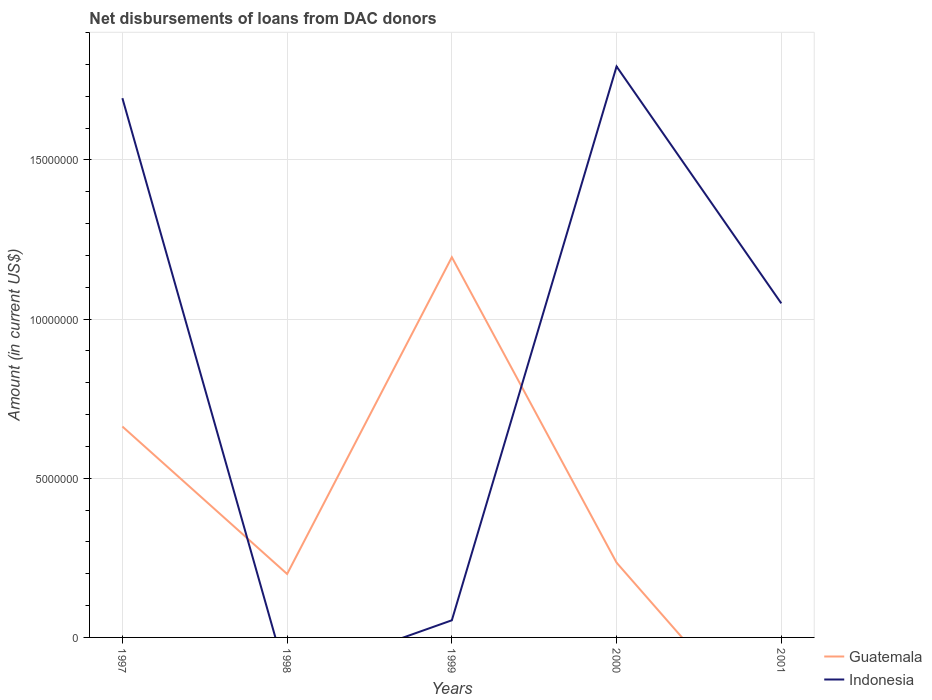Does the line corresponding to Indonesia intersect with the line corresponding to Guatemala?
Provide a succinct answer. Yes. Across all years, what is the maximum amount of loans disbursed in Guatemala?
Your response must be concise. 0. What is the total amount of loans disbursed in Guatemala in the graph?
Make the answer very short. -9.95e+06. What is the difference between the highest and the second highest amount of loans disbursed in Indonesia?
Give a very brief answer. 1.79e+07. Is the amount of loans disbursed in Indonesia strictly greater than the amount of loans disbursed in Guatemala over the years?
Your answer should be compact. No. What is the difference between two consecutive major ticks on the Y-axis?
Offer a very short reply. 5.00e+06. Are the values on the major ticks of Y-axis written in scientific E-notation?
Make the answer very short. No. Where does the legend appear in the graph?
Your answer should be very brief. Bottom right. How many legend labels are there?
Your answer should be compact. 2. What is the title of the graph?
Offer a terse response. Net disbursements of loans from DAC donors. What is the label or title of the X-axis?
Provide a succinct answer. Years. What is the label or title of the Y-axis?
Your answer should be compact. Amount (in current US$). What is the Amount (in current US$) in Guatemala in 1997?
Your answer should be very brief. 6.62e+06. What is the Amount (in current US$) in Indonesia in 1997?
Ensure brevity in your answer.  1.69e+07. What is the Amount (in current US$) in Guatemala in 1998?
Provide a succinct answer. 1.99e+06. What is the Amount (in current US$) of Guatemala in 1999?
Offer a terse response. 1.19e+07. What is the Amount (in current US$) of Indonesia in 1999?
Give a very brief answer. 5.38e+05. What is the Amount (in current US$) in Guatemala in 2000?
Your response must be concise. 2.35e+06. What is the Amount (in current US$) in Indonesia in 2000?
Provide a short and direct response. 1.79e+07. What is the Amount (in current US$) in Indonesia in 2001?
Offer a terse response. 1.05e+07. Across all years, what is the maximum Amount (in current US$) of Guatemala?
Offer a very short reply. 1.19e+07. Across all years, what is the maximum Amount (in current US$) of Indonesia?
Your answer should be very brief. 1.79e+07. Across all years, what is the minimum Amount (in current US$) of Guatemala?
Keep it short and to the point. 0. Across all years, what is the minimum Amount (in current US$) of Indonesia?
Offer a terse response. 0. What is the total Amount (in current US$) of Guatemala in the graph?
Offer a very short reply. 2.29e+07. What is the total Amount (in current US$) in Indonesia in the graph?
Make the answer very short. 4.59e+07. What is the difference between the Amount (in current US$) in Guatemala in 1997 and that in 1998?
Ensure brevity in your answer.  4.63e+06. What is the difference between the Amount (in current US$) in Guatemala in 1997 and that in 1999?
Give a very brief answer. -5.32e+06. What is the difference between the Amount (in current US$) in Indonesia in 1997 and that in 1999?
Provide a short and direct response. 1.64e+07. What is the difference between the Amount (in current US$) in Guatemala in 1997 and that in 2000?
Ensure brevity in your answer.  4.28e+06. What is the difference between the Amount (in current US$) of Indonesia in 1997 and that in 2000?
Make the answer very short. -9.96e+05. What is the difference between the Amount (in current US$) in Indonesia in 1997 and that in 2001?
Make the answer very short. 6.44e+06. What is the difference between the Amount (in current US$) of Guatemala in 1998 and that in 1999?
Your response must be concise. -9.95e+06. What is the difference between the Amount (in current US$) in Guatemala in 1998 and that in 2000?
Your answer should be compact. -3.56e+05. What is the difference between the Amount (in current US$) in Guatemala in 1999 and that in 2000?
Your response must be concise. 9.60e+06. What is the difference between the Amount (in current US$) in Indonesia in 1999 and that in 2000?
Ensure brevity in your answer.  -1.74e+07. What is the difference between the Amount (in current US$) of Indonesia in 1999 and that in 2001?
Provide a succinct answer. -9.96e+06. What is the difference between the Amount (in current US$) in Indonesia in 2000 and that in 2001?
Offer a terse response. 7.44e+06. What is the difference between the Amount (in current US$) in Guatemala in 1997 and the Amount (in current US$) in Indonesia in 1999?
Provide a short and direct response. 6.09e+06. What is the difference between the Amount (in current US$) of Guatemala in 1997 and the Amount (in current US$) of Indonesia in 2000?
Keep it short and to the point. -1.13e+07. What is the difference between the Amount (in current US$) in Guatemala in 1997 and the Amount (in current US$) in Indonesia in 2001?
Provide a succinct answer. -3.87e+06. What is the difference between the Amount (in current US$) of Guatemala in 1998 and the Amount (in current US$) of Indonesia in 1999?
Offer a very short reply. 1.46e+06. What is the difference between the Amount (in current US$) in Guatemala in 1998 and the Amount (in current US$) in Indonesia in 2000?
Ensure brevity in your answer.  -1.59e+07. What is the difference between the Amount (in current US$) in Guatemala in 1998 and the Amount (in current US$) in Indonesia in 2001?
Offer a terse response. -8.50e+06. What is the difference between the Amount (in current US$) of Guatemala in 1999 and the Amount (in current US$) of Indonesia in 2000?
Your answer should be very brief. -5.99e+06. What is the difference between the Amount (in current US$) in Guatemala in 1999 and the Amount (in current US$) in Indonesia in 2001?
Offer a very short reply. 1.45e+06. What is the difference between the Amount (in current US$) of Guatemala in 2000 and the Amount (in current US$) of Indonesia in 2001?
Provide a succinct answer. -8.14e+06. What is the average Amount (in current US$) in Guatemala per year?
Make the answer very short. 4.58e+06. What is the average Amount (in current US$) of Indonesia per year?
Your answer should be very brief. 9.18e+06. In the year 1997, what is the difference between the Amount (in current US$) in Guatemala and Amount (in current US$) in Indonesia?
Give a very brief answer. -1.03e+07. In the year 1999, what is the difference between the Amount (in current US$) in Guatemala and Amount (in current US$) in Indonesia?
Offer a terse response. 1.14e+07. In the year 2000, what is the difference between the Amount (in current US$) in Guatemala and Amount (in current US$) in Indonesia?
Your answer should be compact. -1.56e+07. What is the ratio of the Amount (in current US$) in Guatemala in 1997 to that in 1998?
Give a very brief answer. 3.32. What is the ratio of the Amount (in current US$) of Guatemala in 1997 to that in 1999?
Provide a short and direct response. 0.55. What is the ratio of the Amount (in current US$) of Indonesia in 1997 to that in 1999?
Make the answer very short. 31.49. What is the ratio of the Amount (in current US$) in Guatemala in 1997 to that in 2000?
Make the answer very short. 2.82. What is the ratio of the Amount (in current US$) of Indonesia in 1997 to that in 2000?
Your answer should be compact. 0.94. What is the ratio of the Amount (in current US$) of Indonesia in 1997 to that in 2001?
Provide a succinct answer. 1.61. What is the ratio of the Amount (in current US$) in Guatemala in 1998 to that in 1999?
Provide a short and direct response. 0.17. What is the ratio of the Amount (in current US$) in Guatemala in 1998 to that in 2000?
Give a very brief answer. 0.85. What is the ratio of the Amount (in current US$) of Guatemala in 1999 to that in 2000?
Ensure brevity in your answer.  5.08. What is the ratio of the Amount (in current US$) of Indonesia in 1999 to that in 2001?
Your answer should be compact. 0.05. What is the ratio of the Amount (in current US$) in Indonesia in 2000 to that in 2001?
Offer a very short reply. 1.71. What is the difference between the highest and the second highest Amount (in current US$) of Guatemala?
Your answer should be compact. 5.32e+06. What is the difference between the highest and the second highest Amount (in current US$) of Indonesia?
Keep it short and to the point. 9.96e+05. What is the difference between the highest and the lowest Amount (in current US$) of Guatemala?
Your answer should be very brief. 1.19e+07. What is the difference between the highest and the lowest Amount (in current US$) in Indonesia?
Your answer should be compact. 1.79e+07. 